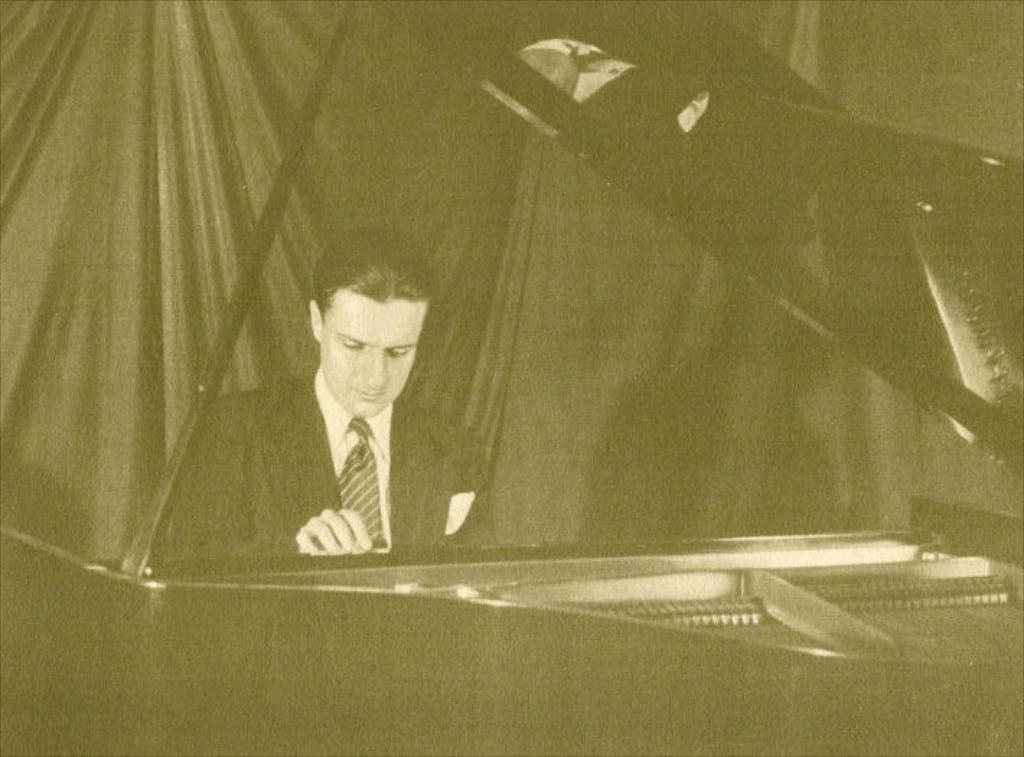What is the color scheme of the image? The image is black and white. What can be seen in the foreground of the image? There is a person sitting in front of a piano. What is visible in the background of the image? There is a curtain in the background of the image. What type of breakfast is being served at the airport in the image? There is no airport or breakfast present in the image; it features a person sitting in front of a piano with a black and white color scheme and a curtain in the background. 